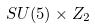Convert formula to latex. <formula><loc_0><loc_0><loc_500><loc_500>S U ( 5 ) \times Z _ { 2 }</formula> 